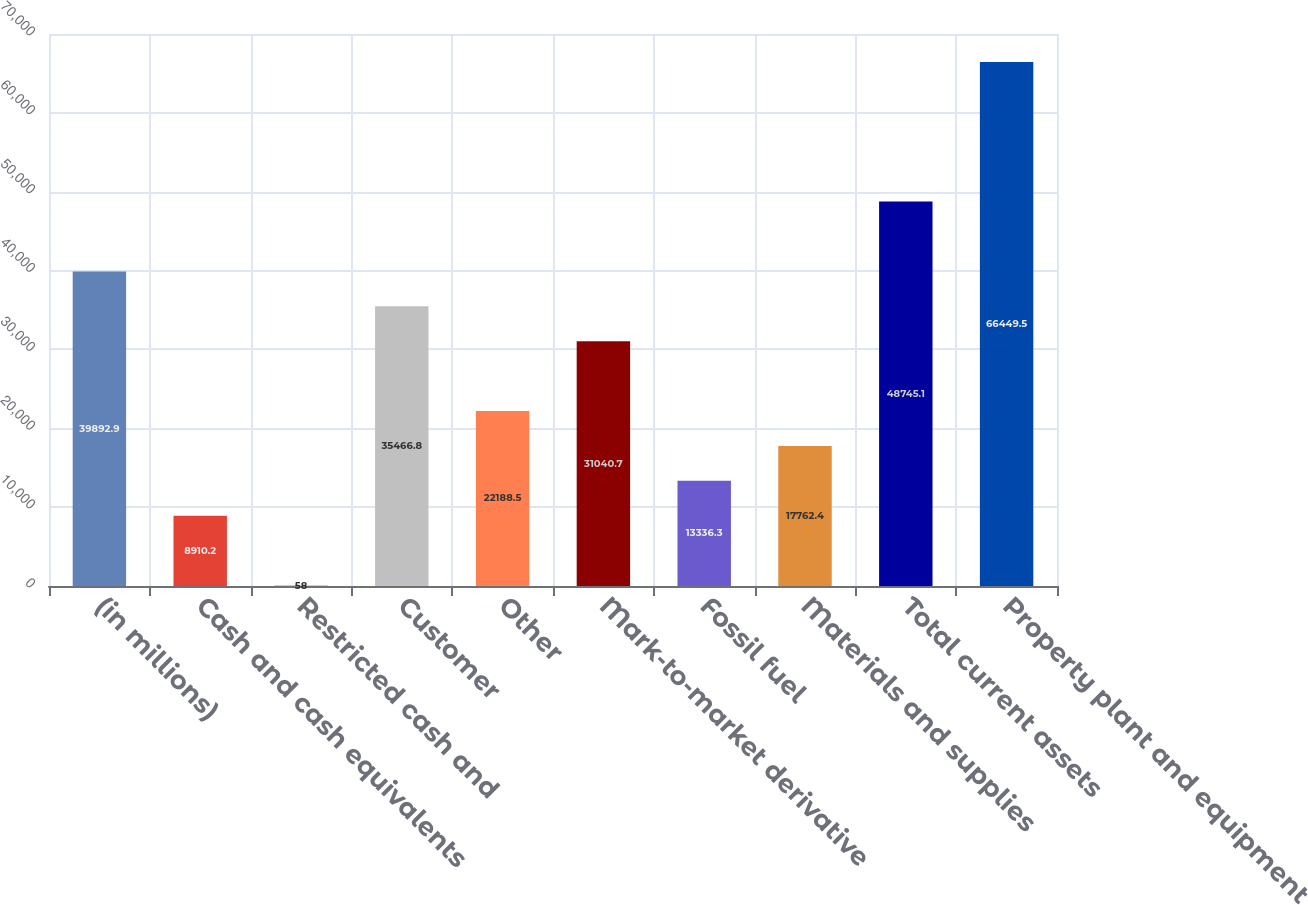<chart> <loc_0><loc_0><loc_500><loc_500><bar_chart><fcel>(in millions)<fcel>Cash and cash equivalents<fcel>Restricted cash and<fcel>Customer<fcel>Other<fcel>Mark-to-market derivative<fcel>Fossil fuel<fcel>Materials and supplies<fcel>Total current assets<fcel>Property plant and equipment<nl><fcel>39892.9<fcel>8910.2<fcel>58<fcel>35466.8<fcel>22188.5<fcel>31040.7<fcel>13336.3<fcel>17762.4<fcel>48745.1<fcel>66449.5<nl></chart> 